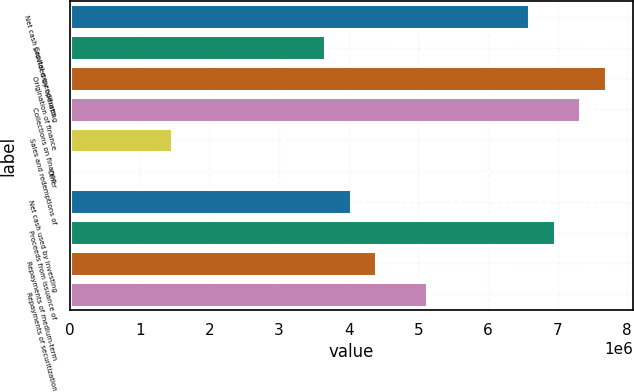Convert chart to OTSL. <chart><loc_0><loc_0><loc_500><loc_500><bar_chart><fcel>Net cash provided by operating<fcel>Capital expenditures<fcel>Origination of finance<fcel>Collections on finance<fcel>Sales and redemptions of<fcel>Other<fcel>Net cash used by investing<fcel>Proceeds from issuance of<fcel>Repayments of medium-term<fcel>Repayments of securitization<nl><fcel>6.59576e+06<fcel>3.6645e+06<fcel>7.69499e+06<fcel>7.32858e+06<fcel>1.46604e+06<fcel>411<fcel>4.0309e+06<fcel>6.96217e+06<fcel>4.39731e+06<fcel>5.13013e+06<nl></chart> 